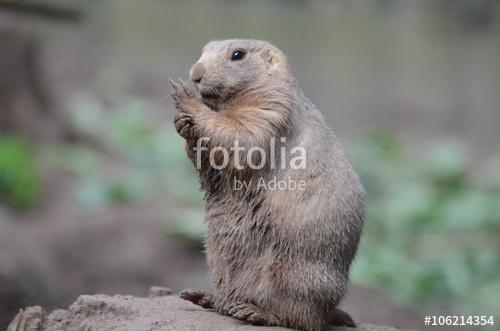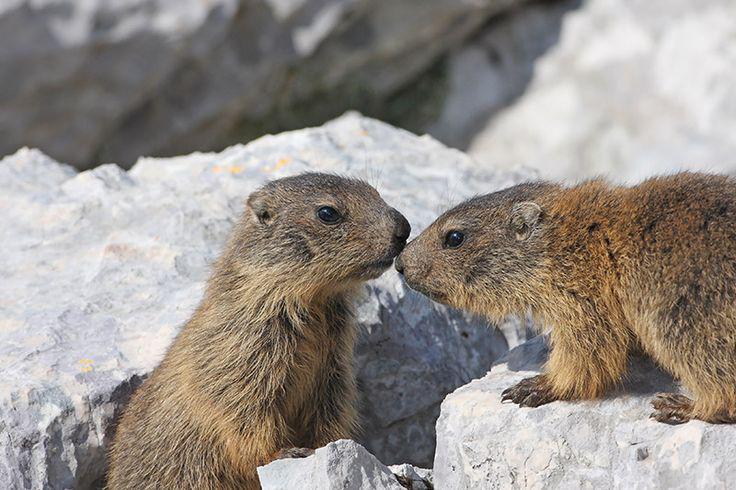The first image is the image on the left, the second image is the image on the right. Considering the images on both sides, is "An image shows marmot with hands raised and close to each other." valid? Answer yes or no. Yes. 